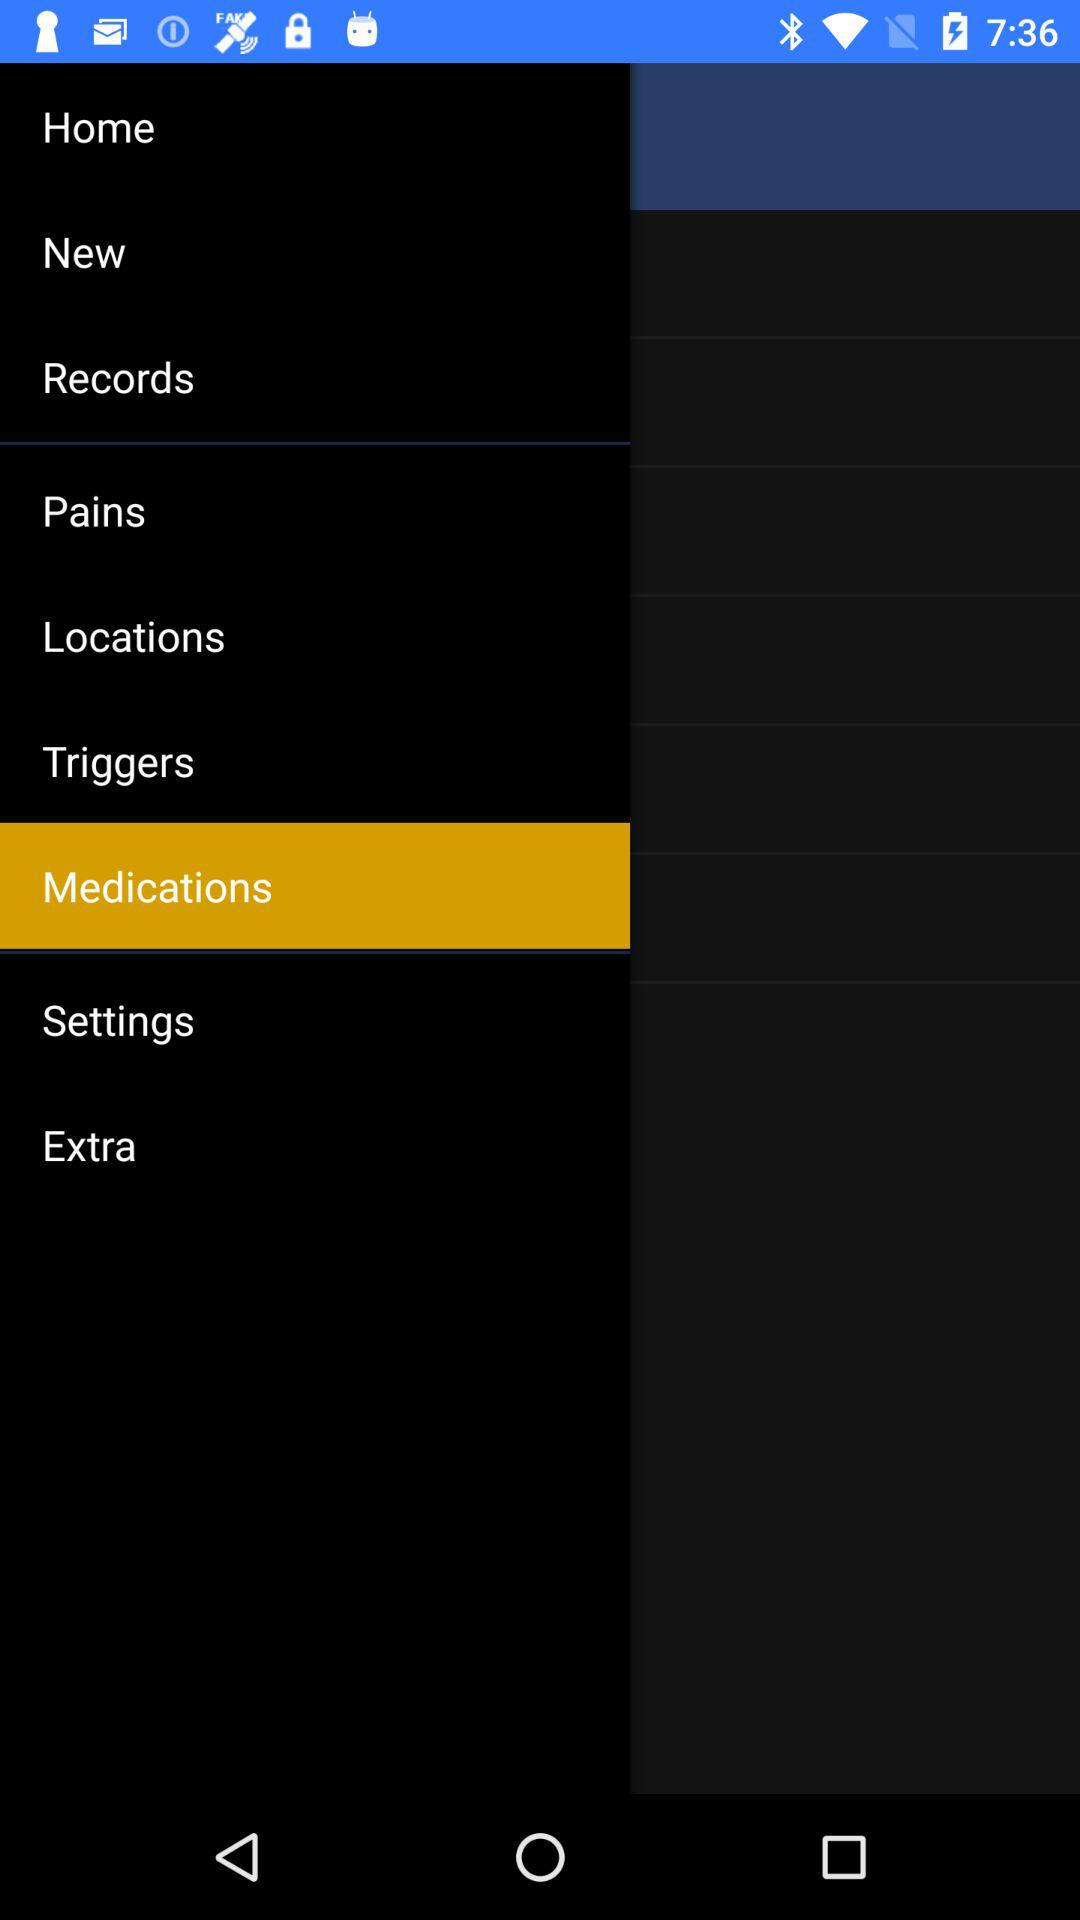What option has been selected? The option that has been selected is "Medications". 